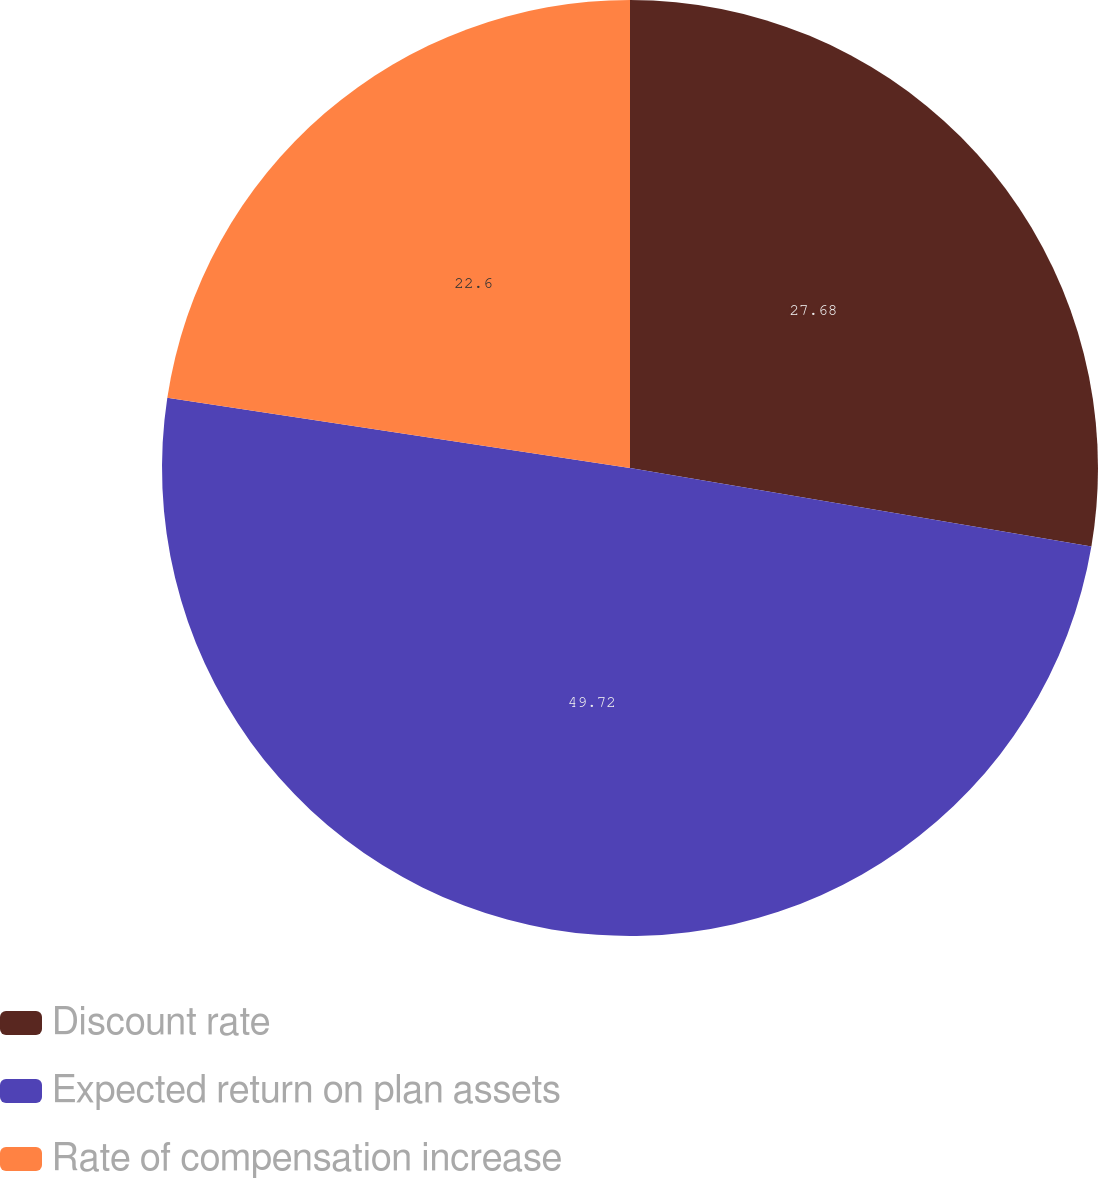Convert chart. <chart><loc_0><loc_0><loc_500><loc_500><pie_chart><fcel>Discount rate<fcel>Expected return on plan assets<fcel>Rate of compensation increase<nl><fcel>27.68%<fcel>49.72%<fcel>22.6%<nl></chart> 